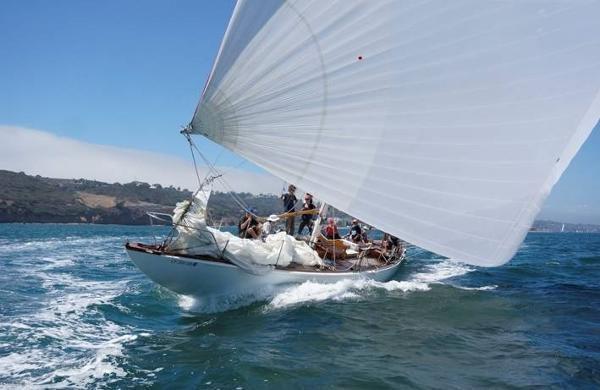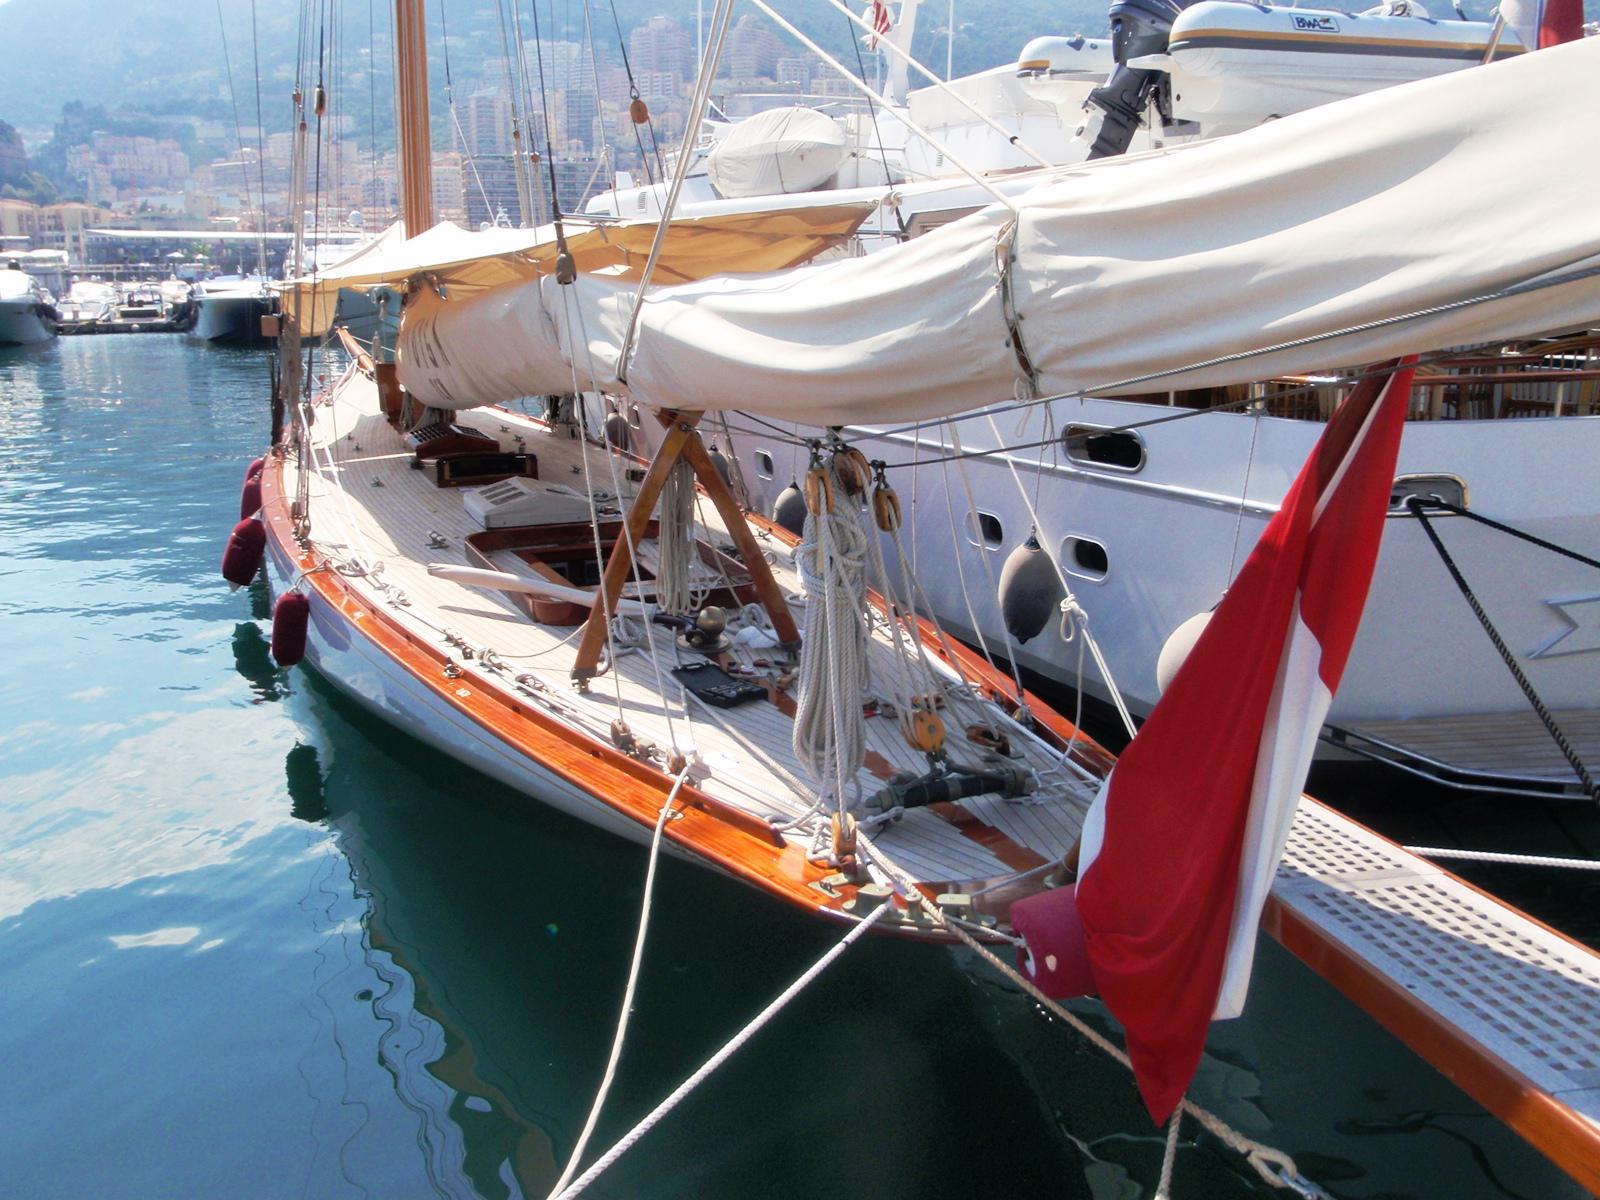The first image is the image on the left, the second image is the image on the right. For the images shown, is this caption "A sailboat in one image has white billowing sails, but the sails of a boat in the other image are furled." true? Answer yes or no. Yes. The first image is the image on the left, the second image is the image on the right. Evaluate the accuracy of this statement regarding the images: "The boat in the left image has a red flag hanging from its rear.". Is it true? Answer yes or no. Yes. 